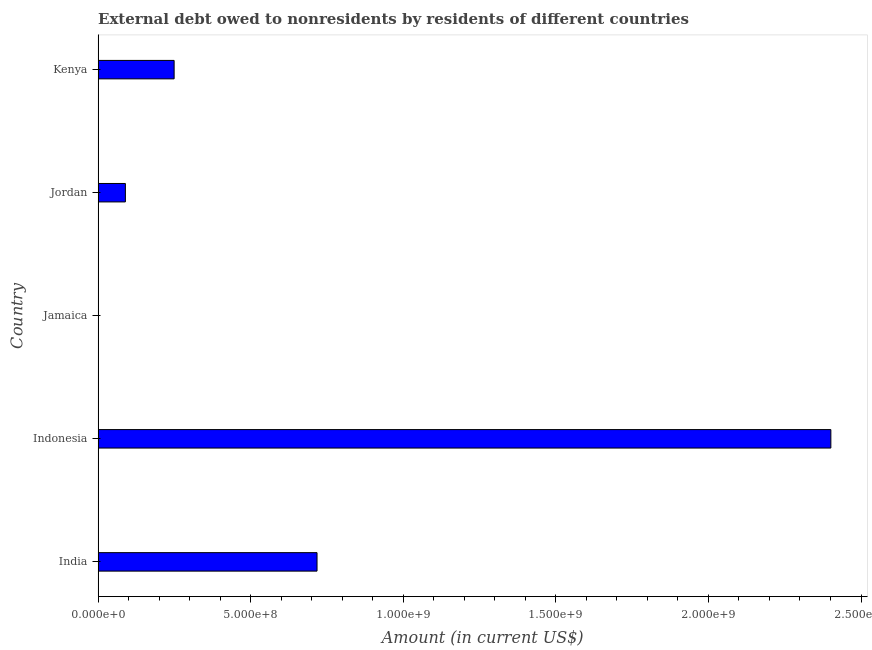What is the title of the graph?
Provide a short and direct response. External debt owed to nonresidents by residents of different countries. What is the debt in India?
Offer a very short reply. 7.17e+08. Across all countries, what is the maximum debt?
Give a very brief answer. 2.40e+09. What is the sum of the debt?
Provide a short and direct response. 3.46e+09. What is the difference between the debt in India and Kenya?
Keep it short and to the point. 4.68e+08. What is the average debt per country?
Your answer should be compact. 6.91e+08. What is the median debt?
Your answer should be compact. 2.49e+08. In how many countries, is the debt greater than 700000000 US$?
Provide a short and direct response. 2. What is the ratio of the debt in Indonesia to that in Kenya?
Keep it short and to the point. 9.64. Is the debt in Indonesia less than that in Kenya?
Your answer should be compact. No. Is the difference between the debt in Jordan and Kenya greater than the difference between any two countries?
Provide a short and direct response. No. What is the difference between the highest and the second highest debt?
Keep it short and to the point. 1.68e+09. What is the difference between the highest and the lowest debt?
Offer a terse response. 2.40e+09. In how many countries, is the debt greater than the average debt taken over all countries?
Make the answer very short. 2. How many countries are there in the graph?
Offer a terse response. 5. What is the difference between two consecutive major ticks on the X-axis?
Offer a very short reply. 5.00e+08. Are the values on the major ticks of X-axis written in scientific E-notation?
Your answer should be very brief. Yes. What is the Amount (in current US$) of India?
Your answer should be compact. 7.17e+08. What is the Amount (in current US$) in Indonesia?
Offer a very short reply. 2.40e+09. What is the Amount (in current US$) in Jamaica?
Your answer should be compact. 0. What is the Amount (in current US$) in Jordan?
Provide a short and direct response. 8.94e+07. What is the Amount (in current US$) of Kenya?
Keep it short and to the point. 2.49e+08. What is the difference between the Amount (in current US$) in India and Indonesia?
Ensure brevity in your answer.  -1.68e+09. What is the difference between the Amount (in current US$) in India and Jordan?
Give a very brief answer. 6.28e+08. What is the difference between the Amount (in current US$) in India and Kenya?
Keep it short and to the point. 4.68e+08. What is the difference between the Amount (in current US$) in Indonesia and Jordan?
Give a very brief answer. 2.31e+09. What is the difference between the Amount (in current US$) in Indonesia and Kenya?
Your answer should be very brief. 2.15e+09. What is the difference between the Amount (in current US$) in Jordan and Kenya?
Make the answer very short. -1.60e+08. What is the ratio of the Amount (in current US$) in India to that in Indonesia?
Ensure brevity in your answer.  0.3. What is the ratio of the Amount (in current US$) in India to that in Jordan?
Provide a succinct answer. 8.03. What is the ratio of the Amount (in current US$) in India to that in Kenya?
Offer a very short reply. 2.88. What is the ratio of the Amount (in current US$) in Indonesia to that in Jordan?
Offer a terse response. 26.87. What is the ratio of the Amount (in current US$) in Indonesia to that in Kenya?
Your answer should be compact. 9.64. What is the ratio of the Amount (in current US$) in Jordan to that in Kenya?
Your answer should be compact. 0.36. 